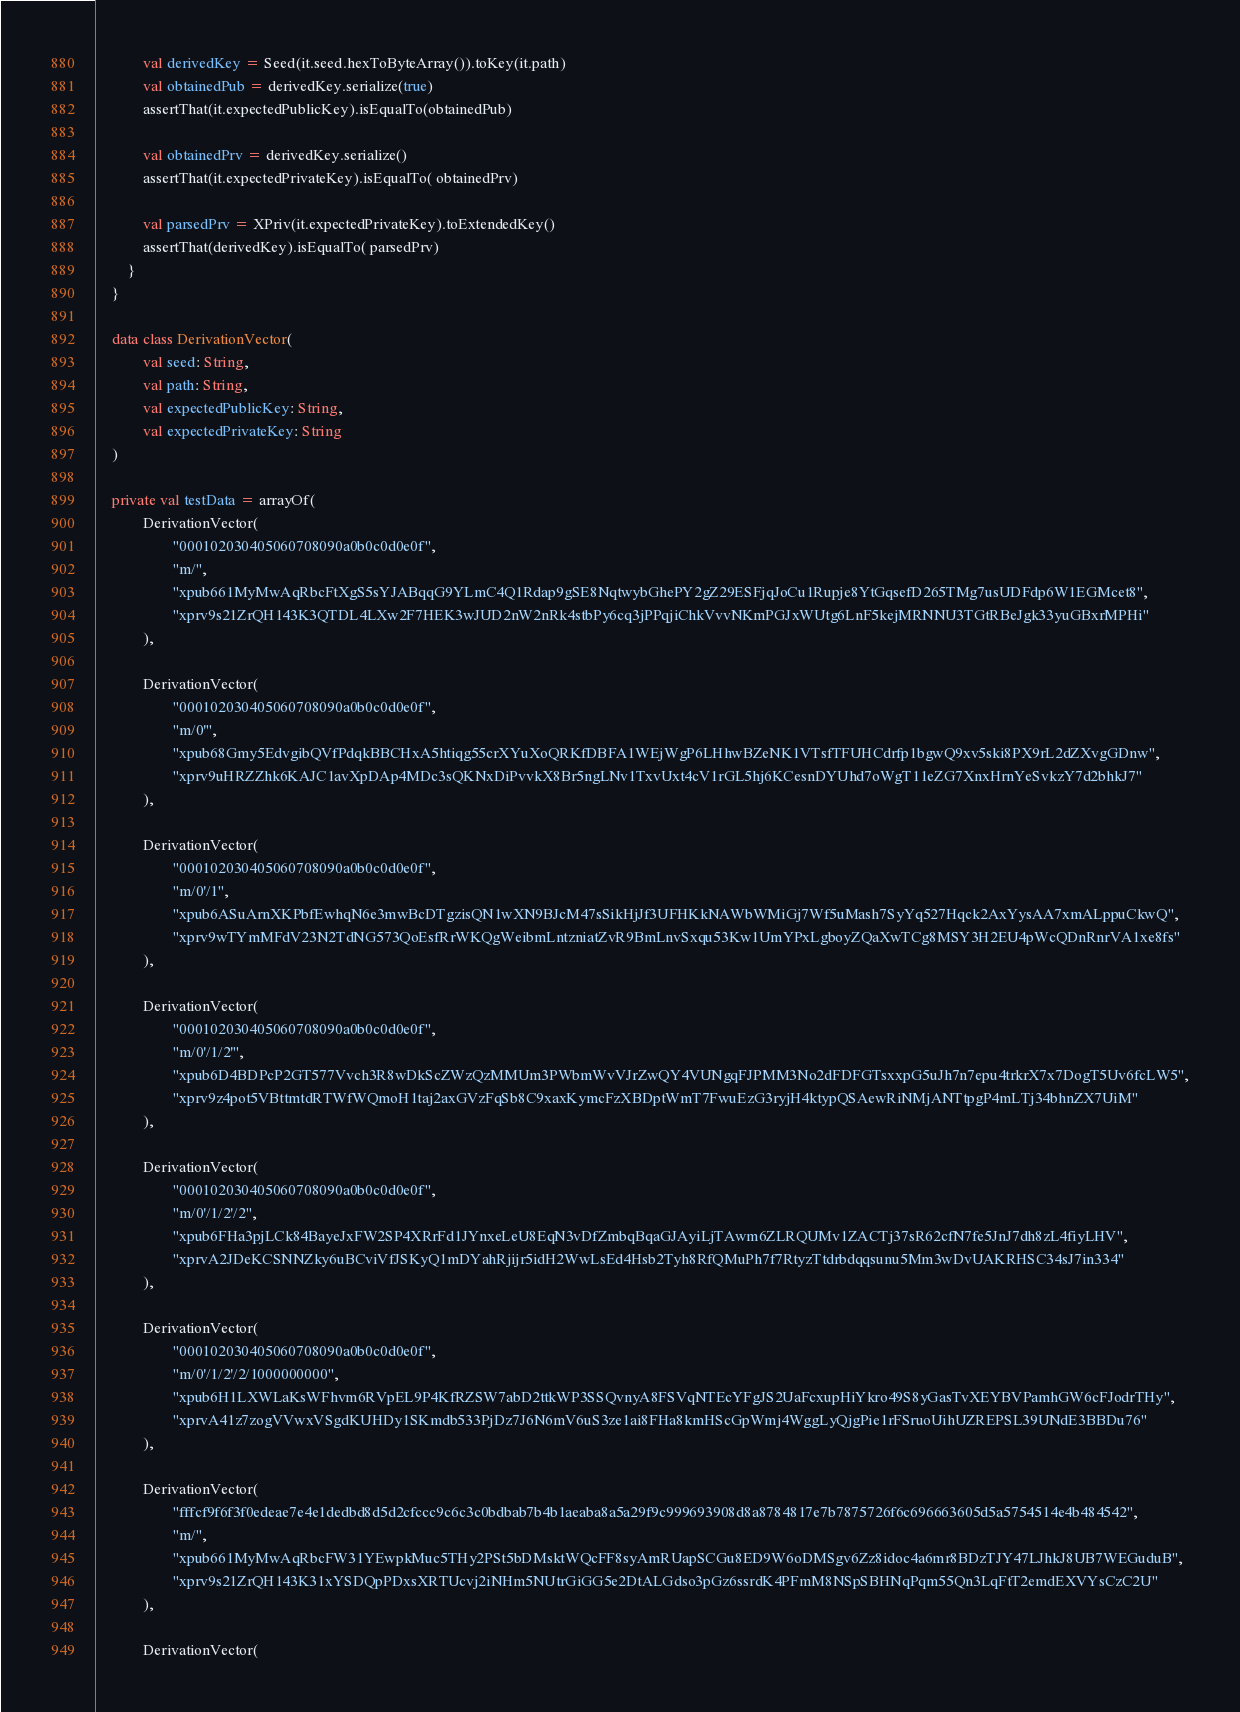<code> <loc_0><loc_0><loc_500><loc_500><_Kotlin_>            val derivedKey = Seed(it.seed.hexToByteArray()).toKey(it.path)
            val obtainedPub = derivedKey.serialize(true)
            assertThat(it.expectedPublicKey).isEqualTo(obtainedPub)

            val obtainedPrv = derivedKey.serialize()
            assertThat(it.expectedPrivateKey).isEqualTo( obtainedPrv)

            val parsedPrv = XPriv(it.expectedPrivateKey).toExtendedKey()
            assertThat(derivedKey).isEqualTo( parsedPrv)
        }
    }

    data class DerivationVector(
            val seed: String,
            val path: String,
            val expectedPublicKey: String,
            val expectedPrivateKey: String
    )

    private val testData = arrayOf(
            DerivationVector(
                    "000102030405060708090a0b0c0d0e0f",
                    "m/",
                    "xpub661MyMwAqRbcFtXgS5sYJABqqG9YLmC4Q1Rdap9gSE8NqtwybGhePY2gZ29ESFjqJoCu1Rupje8YtGqsefD265TMg7usUDFdp6W1EGMcet8",
                    "xprv9s21ZrQH143K3QTDL4LXw2F7HEK3wJUD2nW2nRk4stbPy6cq3jPPqjiChkVvvNKmPGJxWUtg6LnF5kejMRNNU3TGtRBeJgk33yuGBxrMPHi"
            ),

            DerivationVector(
                    "000102030405060708090a0b0c0d0e0f",
                    "m/0'",
                    "xpub68Gmy5EdvgibQVfPdqkBBCHxA5htiqg55crXYuXoQRKfDBFA1WEjWgP6LHhwBZeNK1VTsfTFUHCdrfp1bgwQ9xv5ski8PX9rL2dZXvgGDnw",
                    "xprv9uHRZZhk6KAJC1avXpDAp4MDc3sQKNxDiPvvkX8Br5ngLNv1TxvUxt4cV1rGL5hj6KCesnDYUhd7oWgT11eZG7XnxHrnYeSvkzY7d2bhkJ7"
            ),

            DerivationVector(
                    "000102030405060708090a0b0c0d0e0f",
                    "m/0'/1",
                    "xpub6ASuArnXKPbfEwhqN6e3mwBcDTgzisQN1wXN9BJcM47sSikHjJf3UFHKkNAWbWMiGj7Wf5uMash7SyYq527Hqck2AxYysAA7xmALppuCkwQ",
                    "xprv9wTYmMFdV23N2TdNG573QoEsfRrWKQgWeibmLntzniatZvR9BmLnvSxqu53Kw1UmYPxLgboyZQaXwTCg8MSY3H2EU4pWcQDnRnrVA1xe8fs"
            ),

            DerivationVector(
                    "000102030405060708090a0b0c0d0e0f",
                    "m/0'/1/2'",
                    "xpub6D4BDPcP2GT577Vvch3R8wDkScZWzQzMMUm3PWbmWvVJrZwQY4VUNgqFJPMM3No2dFDFGTsxxpG5uJh7n7epu4trkrX7x7DogT5Uv6fcLW5",
                    "xprv9z4pot5VBttmtdRTWfWQmoH1taj2axGVzFqSb8C9xaxKymcFzXBDptWmT7FwuEzG3ryjH4ktypQSAewRiNMjANTtpgP4mLTj34bhnZX7UiM"
            ),

            DerivationVector(
                    "000102030405060708090a0b0c0d0e0f",
                    "m/0'/1/2'/2",
                    "xpub6FHa3pjLCk84BayeJxFW2SP4XRrFd1JYnxeLeU8EqN3vDfZmbqBqaGJAyiLjTAwm6ZLRQUMv1ZACTj37sR62cfN7fe5JnJ7dh8zL4fiyLHV",
                    "xprvA2JDeKCSNNZky6uBCviVfJSKyQ1mDYahRjijr5idH2WwLsEd4Hsb2Tyh8RfQMuPh7f7RtyzTtdrbdqqsunu5Mm3wDvUAKRHSC34sJ7in334"
            ),

            DerivationVector(
                    "000102030405060708090a0b0c0d0e0f",
                    "m/0'/1/2'/2/1000000000",
                    "xpub6H1LXWLaKsWFhvm6RVpEL9P4KfRZSW7abD2ttkWP3SSQvnyA8FSVqNTEcYFgJS2UaFcxupHiYkro49S8yGasTvXEYBVPamhGW6cFJodrTHy",
                    "xprvA41z7zogVVwxVSgdKUHDy1SKmdb533PjDz7J6N6mV6uS3ze1ai8FHa8kmHScGpWmj4WggLyQjgPie1rFSruoUihUZREPSL39UNdE3BBDu76"
            ),

            DerivationVector(
                    "fffcf9f6f3f0edeae7e4e1dedbd8d5d2cfccc9c6c3c0bdbab7b4b1aeaba8a5a29f9c999693908d8a8784817e7b7875726f6c696663605d5a5754514e4b484542",
                    "m/",
                    "xpub661MyMwAqRbcFW31YEwpkMuc5THy2PSt5bDMsktWQcFF8syAmRUapSCGu8ED9W6oDMSgv6Zz8idoc4a6mr8BDzTJY47LJhkJ8UB7WEGuduB",
                    "xprv9s21ZrQH143K31xYSDQpPDxsXRTUcvj2iNHm5NUtrGiGG5e2DtALGdso3pGz6ssrdK4PFmM8NSpSBHNqPqm55Qn3LqFtT2emdEXVYsCzC2U"
            ),

            DerivationVector(</code> 